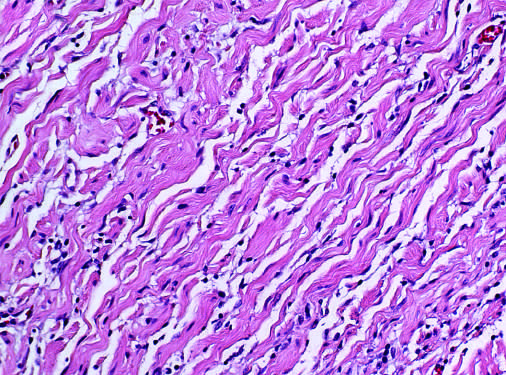re wavy collagen bundles likened to carrot shavings?
Answer the question using a single word or phrase. Yes 